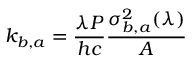Convert formula to latex. <formula><loc_0><loc_0><loc_500><loc_500>k _ { b , a } = \frac { \lambda P } { h c } \frac { \sigma _ { b , a } ^ { 2 } ( \lambda ) } { A }</formula> 